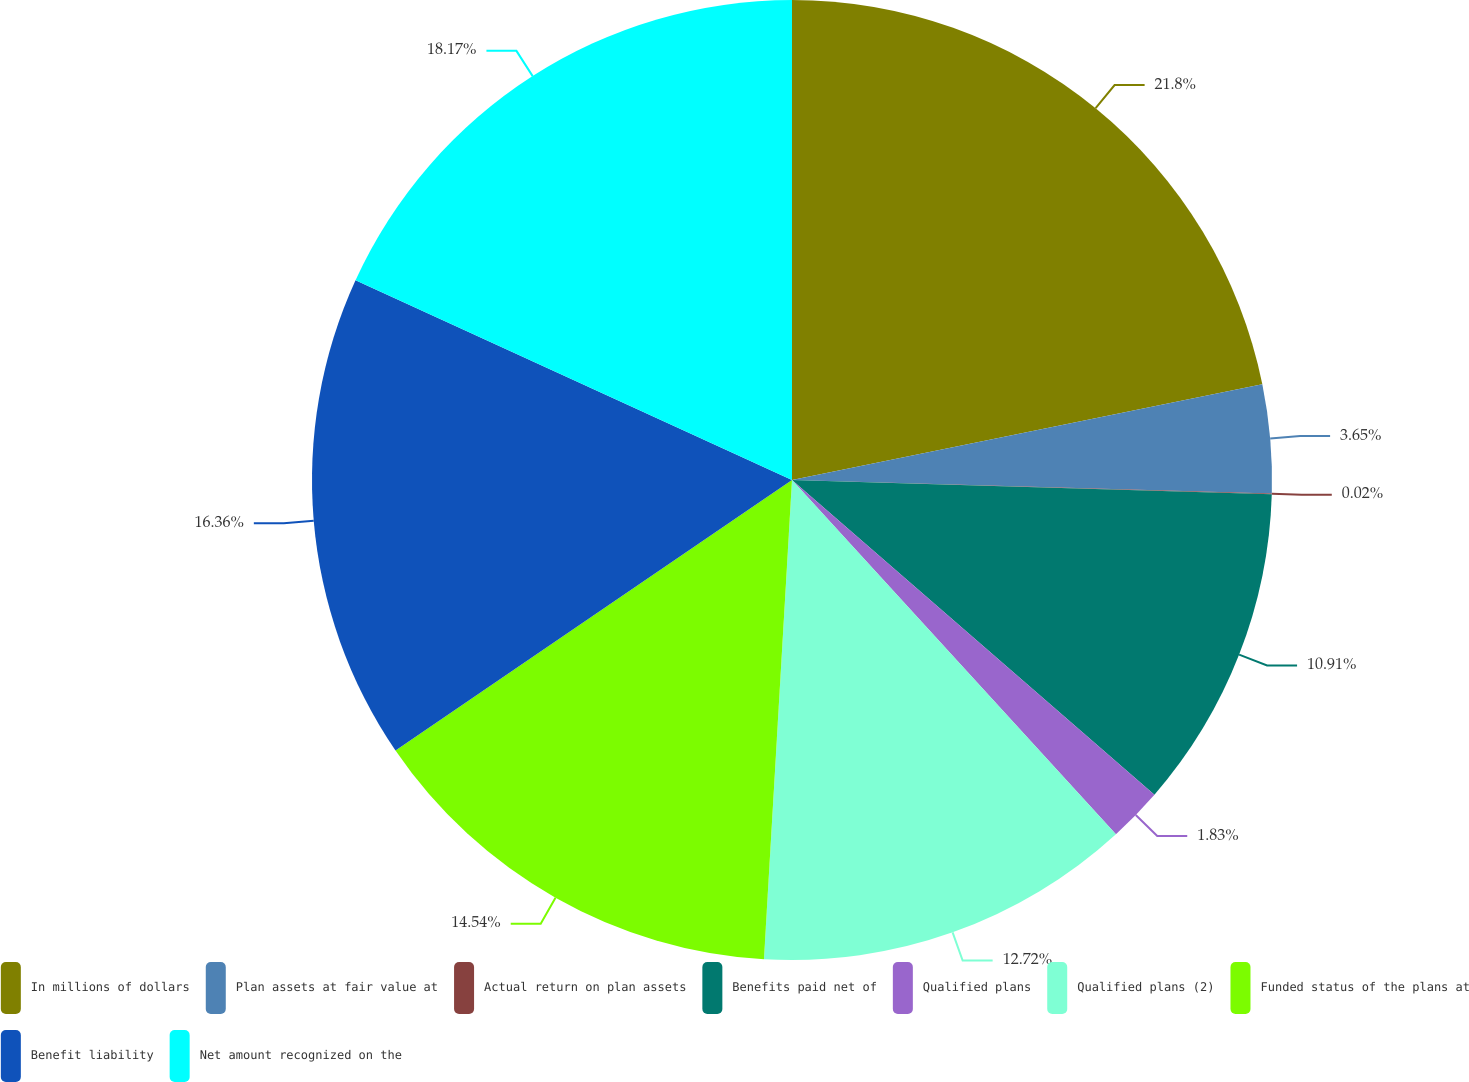<chart> <loc_0><loc_0><loc_500><loc_500><pie_chart><fcel>In millions of dollars<fcel>Plan assets at fair value at<fcel>Actual return on plan assets<fcel>Benefits paid net of<fcel>Qualified plans<fcel>Qualified plans (2)<fcel>Funded status of the plans at<fcel>Benefit liability<fcel>Net amount recognized on the<nl><fcel>21.8%<fcel>3.65%<fcel>0.02%<fcel>10.91%<fcel>1.83%<fcel>12.72%<fcel>14.54%<fcel>16.36%<fcel>18.17%<nl></chart> 